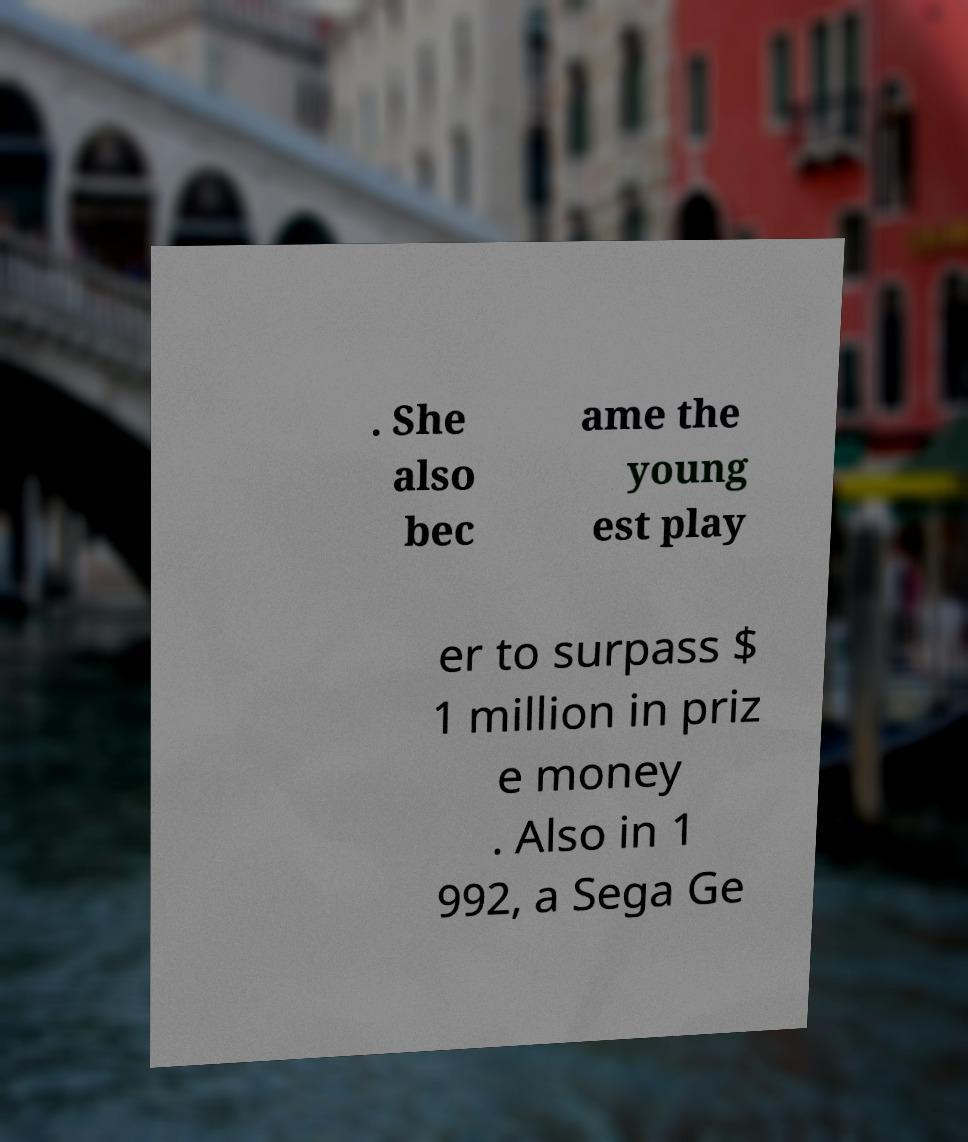Please identify and transcribe the text found in this image. . She also bec ame the young est play er to surpass $ 1 million in priz e money . Also in 1 992, a Sega Ge 